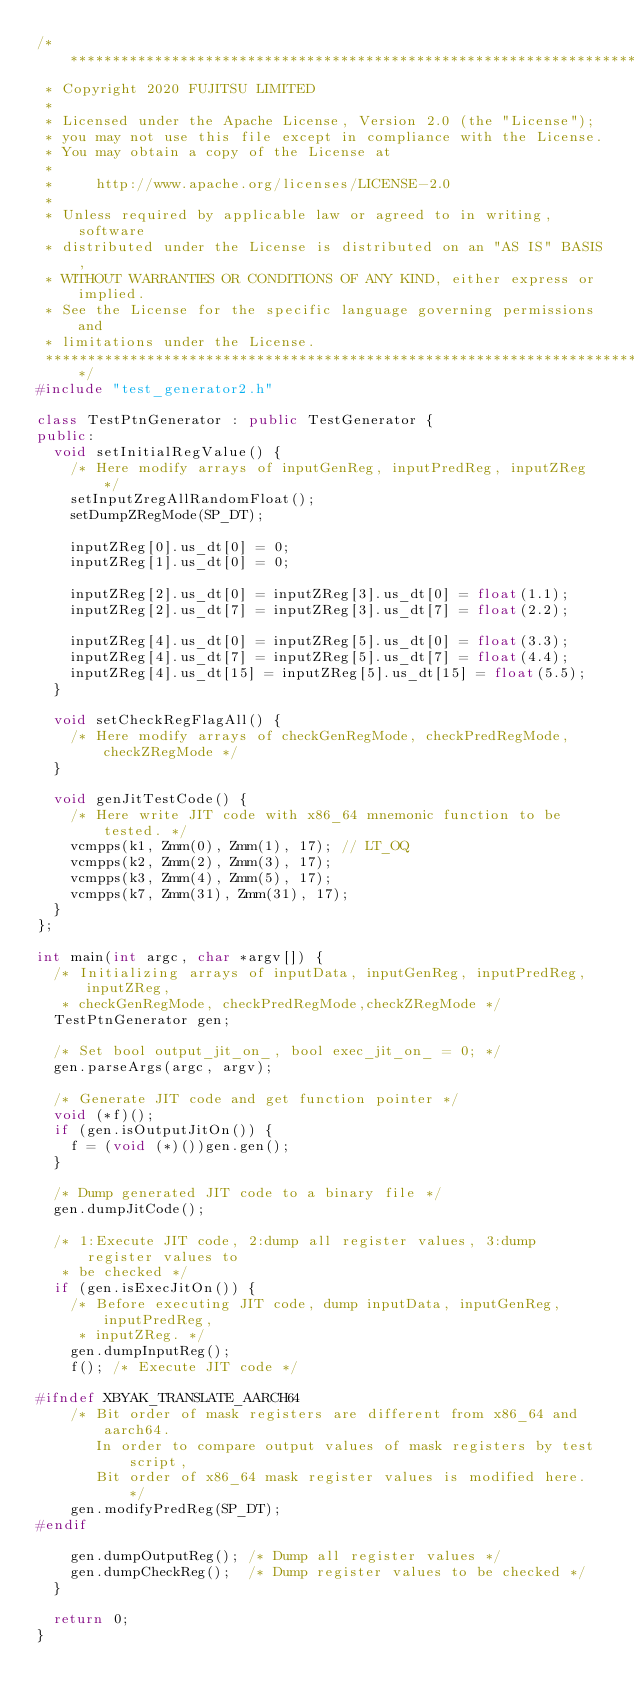Convert code to text. <code><loc_0><loc_0><loc_500><loc_500><_C++_>/*******************************************************************************
 * Copyright 2020 FUJITSU LIMITED
 *
 * Licensed under the Apache License, Version 2.0 (the "License");
 * you may not use this file except in compliance with the License.
 * You may obtain a copy of the License at
 *
 *     http://www.apache.org/licenses/LICENSE-2.0
 *
 * Unless required by applicable law or agreed to in writing, software
 * distributed under the License is distributed on an "AS IS" BASIS,
 * WITHOUT WARRANTIES OR CONDITIONS OF ANY KIND, either express or implied.
 * See the License for the specific language governing permissions and
 * limitations under the License.
 *******************************************************************************/
#include "test_generator2.h"

class TestPtnGenerator : public TestGenerator {
public:
  void setInitialRegValue() {
    /* Here modify arrays of inputGenReg, inputPredReg, inputZReg */
    setInputZregAllRandomFloat();
    setDumpZRegMode(SP_DT);

    inputZReg[0].us_dt[0] = 0;
    inputZReg[1].us_dt[0] = 0;

    inputZReg[2].us_dt[0] = inputZReg[3].us_dt[0] = float(1.1);
    inputZReg[2].us_dt[7] = inputZReg[3].us_dt[7] = float(2.2);

    inputZReg[4].us_dt[0] = inputZReg[5].us_dt[0] = float(3.3);
    inputZReg[4].us_dt[7] = inputZReg[5].us_dt[7] = float(4.4);
    inputZReg[4].us_dt[15] = inputZReg[5].us_dt[15] = float(5.5);
  }

  void setCheckRegFlagAll() {
    /* Here modify arrays of checkGenRegMode, checkPredRegMode, checkZRegMode */
  }

  void genJitTestCode() {
    /* Here write JIT code with x86_64 mnemonic function to be tested. */
    vcmpps(k1, Zmm(0), Zmm(1), 17); // LT_OQ
    vcmpps(k2, Zmm(2), Zmm(3), 17);
    vcmpps(k3, Zmm(4), Zmm(5), 17);
    vcmpps(k7, Zmm(31), Zmm(31), 17);
  }
};

int main(int argc, char *argv[]) {
  /* Initializing arrays of inputData, inputGenReg, inputPredReg, inputZReg,
   * checkGenRegMode, checkPredRegMode,checkZRegMode */
  TestPtnGenerator gen;

  /* Set bool output_jit_on_, bool exec_jit_on_ = 0; */
  gen.parseArgs(argc, argv);

  /* Generate JIT code and get function pointer */
  void (*f)();
  if (gen.isOutputJitOn()) {
    f = (void (*)())gen.gen();
  }

  /* Dump generated JIT code to a binary file */
  gen.dumpJitCode();

  /* 1:Execute JIT code, 2:dump all register values, 3:dump register values to
   * be checked */
  if (gen.isExecJitOn()) {
    /* Before executing JIT code, dump inputData, inputGenReg, inputPredReg,
     * inputZReg. */
    gen.dumpInputReg();
    f(); /* Execute JIT code */

#ifndef XBYAK_TRANSLATE_AARCH64
    /* Bit order of mask registers are different from x86_64 and aarch64.
       In order to compare output values of mask registers by test script,
       Bit order of x86_64 mask register values is modified here. */
    gen.modifyPredReg(SP_DT);
#endif

    gen.dumpOutputReg(); /* Dump all register values */
    gen.dumpCheckReg();  /* Dump register values to be checked */
  }

  return 0;
}
</code> 